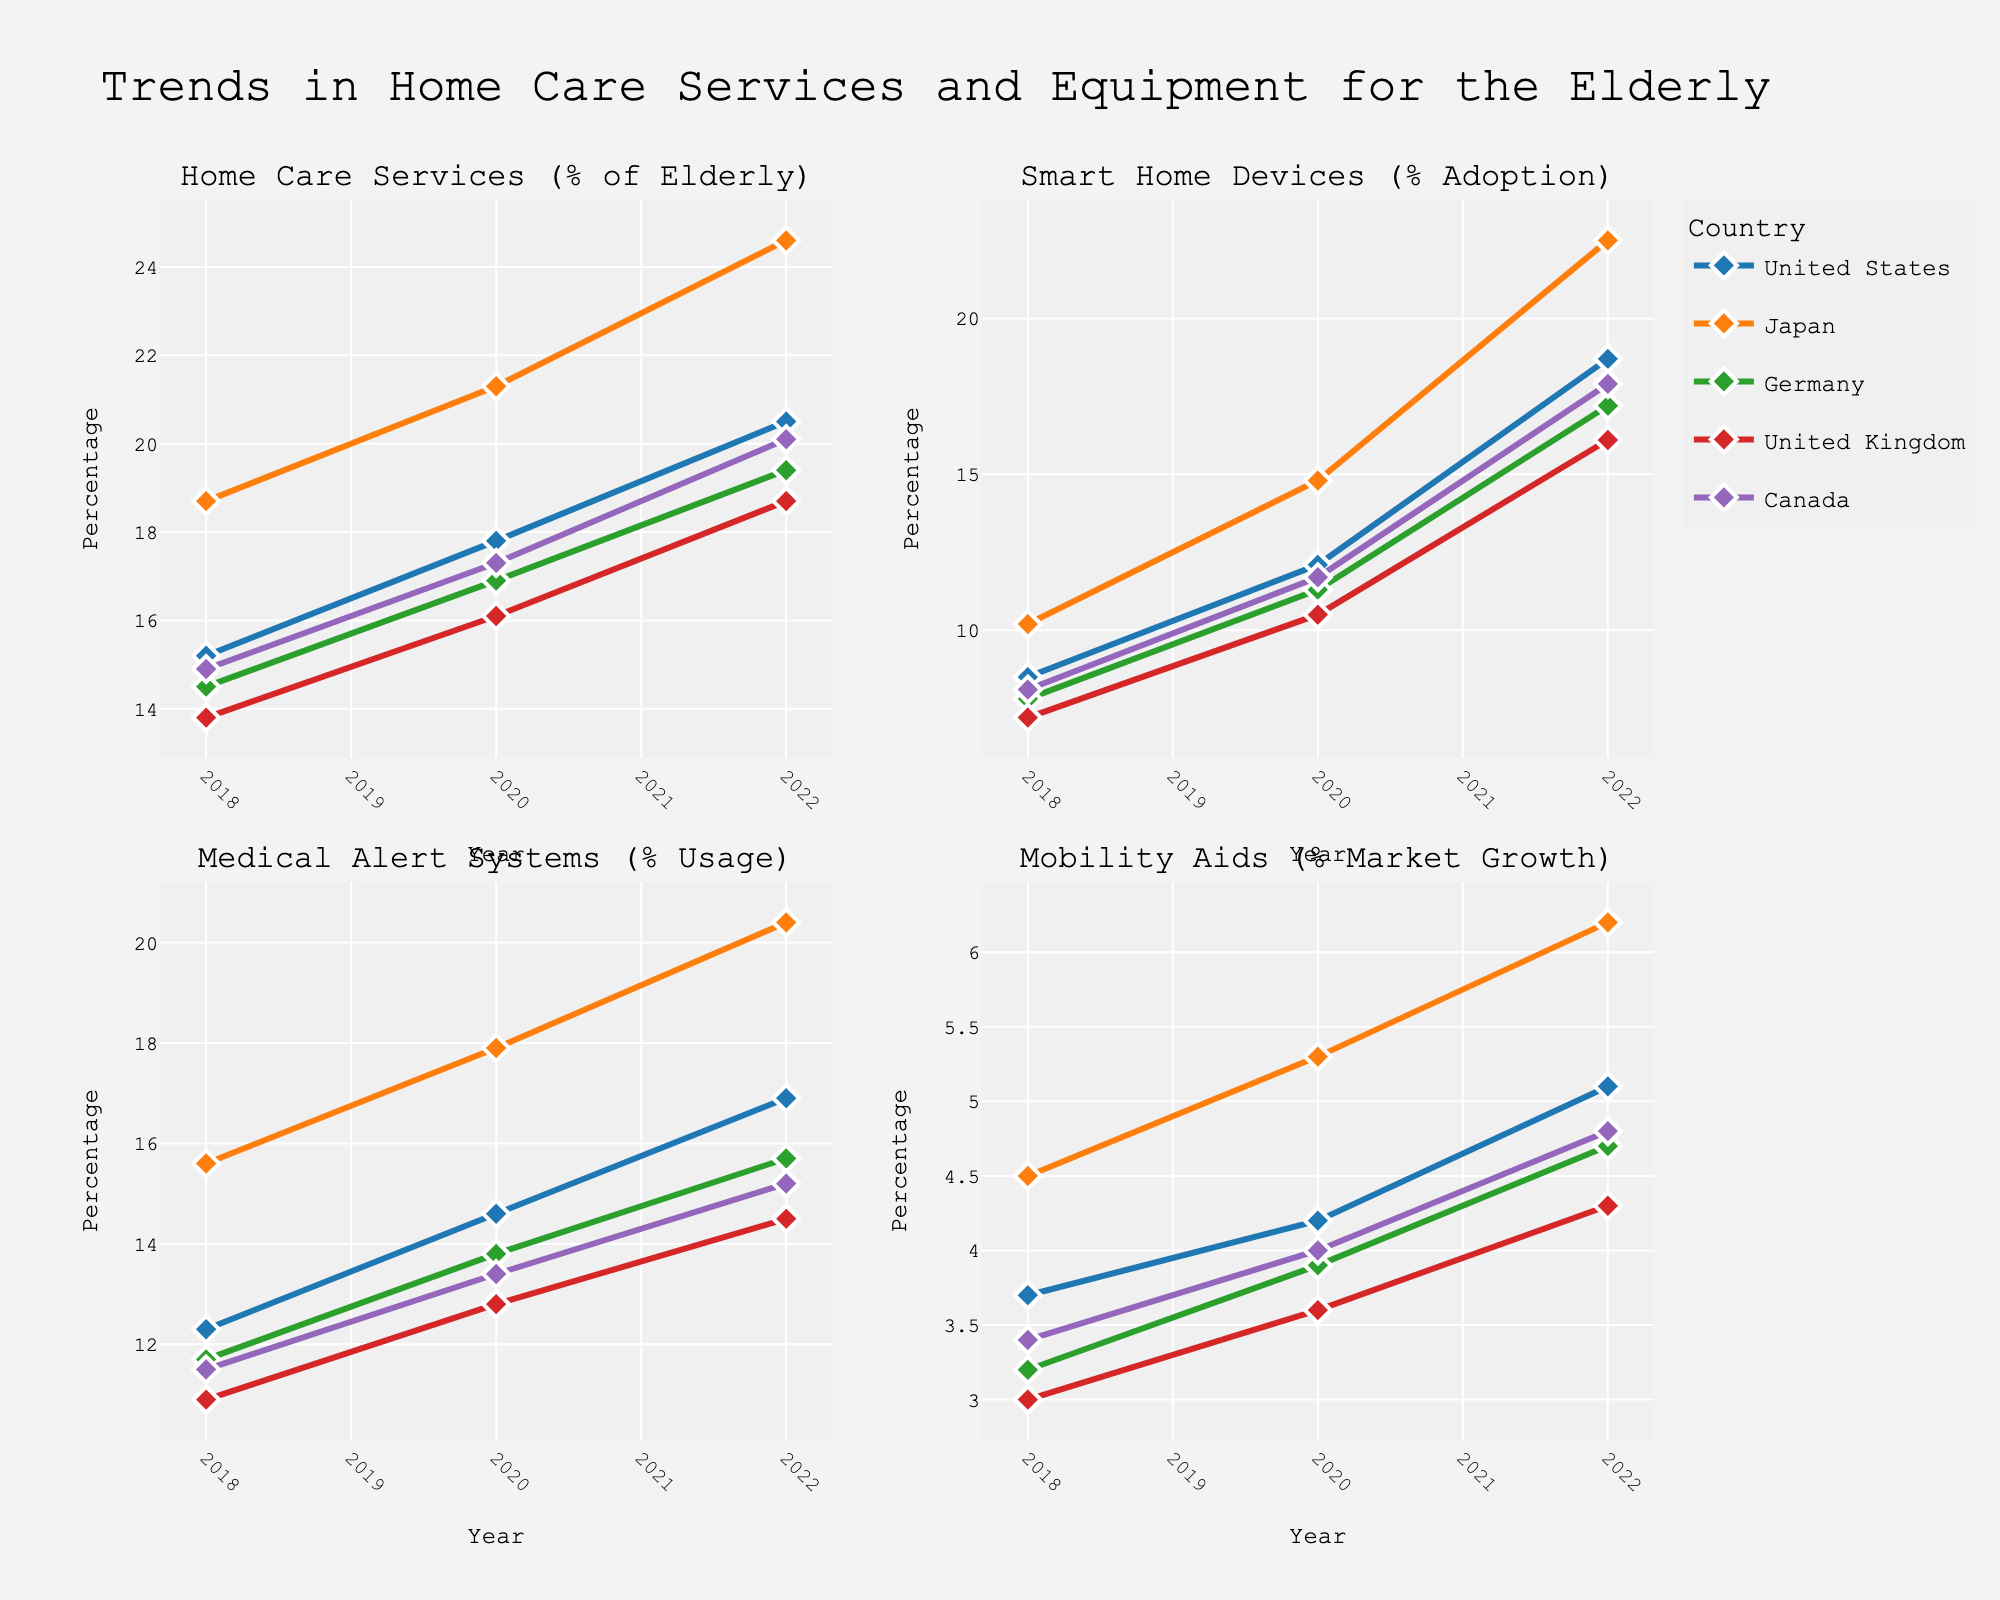Who has the highest water consumption in summer? In the subplot for each landscaping type, check the bar heights for summer. The Lawn subplot has the highest bar at 45 units.
Answer: Lawn Which season has the lowest water consumption for Trees? Look at the Trees subplot and compare the bar heights for each season. The Winter season has the lowest bar at 5 units.
Answer: Winter What is the total water consumption for Shrubs across all seasons? Add up the values from the Shrubs subplot: 15 (Spring) + 20 (Summer) + 10 (Fall) + 5 (Winter) = 50
Answer: 50 Which type of landscaping shows the least difference in water consumption between the highest and lowest seasons? Calculate the difference between the highest and lowest bars for each subplot. Flower Garden: 35 - 5 = 30, Vegetable Garden: 30 - 5 = 25, Shrubs: 20 - 5 = 15, Trees: 15 - 5 = 10, Lawn: 45 - 10 = 35. Trees have the smallest difference of 10.
Answer: Trees What's the average water consumption for Vegetable Garden in Spring and Fall? Add the water consumption values for Vegetable Garden in Spring (20) and Fall (15), then divide by 2. (20 + 15)/2 = 17.5
Answer: 17.5 Compare the water consumption in Summer for Flower Garden and Vegetable Garden. Which one is higher and by how much? Check the bar heights for these subplots in Summer. Flower Garden has 35, Vegetable Garden has 30. The difference is 35 - 30 = 5.
Answer: Flower Garden, by 5 units What is the combined water consumption of all landscaping types in Winter? Add all the Winter values together: Lawn (10) + Flower Garden (5) + Vegetable Garden (5) + Shrubs (5) + Trees (5) = 30
Answer: 30 Which season has the highest overall water consumption for all landscaping types combined? Sum the bars for each season across all subplots: 
Spring: 30+25+20+15+10 = 100 
Summer: 45+35+30+20+15 = 145
Fall: 25+20+15+10+8 = 78
Winter: 10+5+5+5+5 = 30
Summer has the highest at 145.
Answer: Summer What's the difference in water consumption for Lawn between Spring and Fall? Subtract Fall consumption from Spring consumption for Lawn. 30 (Spring) - 25 (Fall) = 5
Answer: 5 